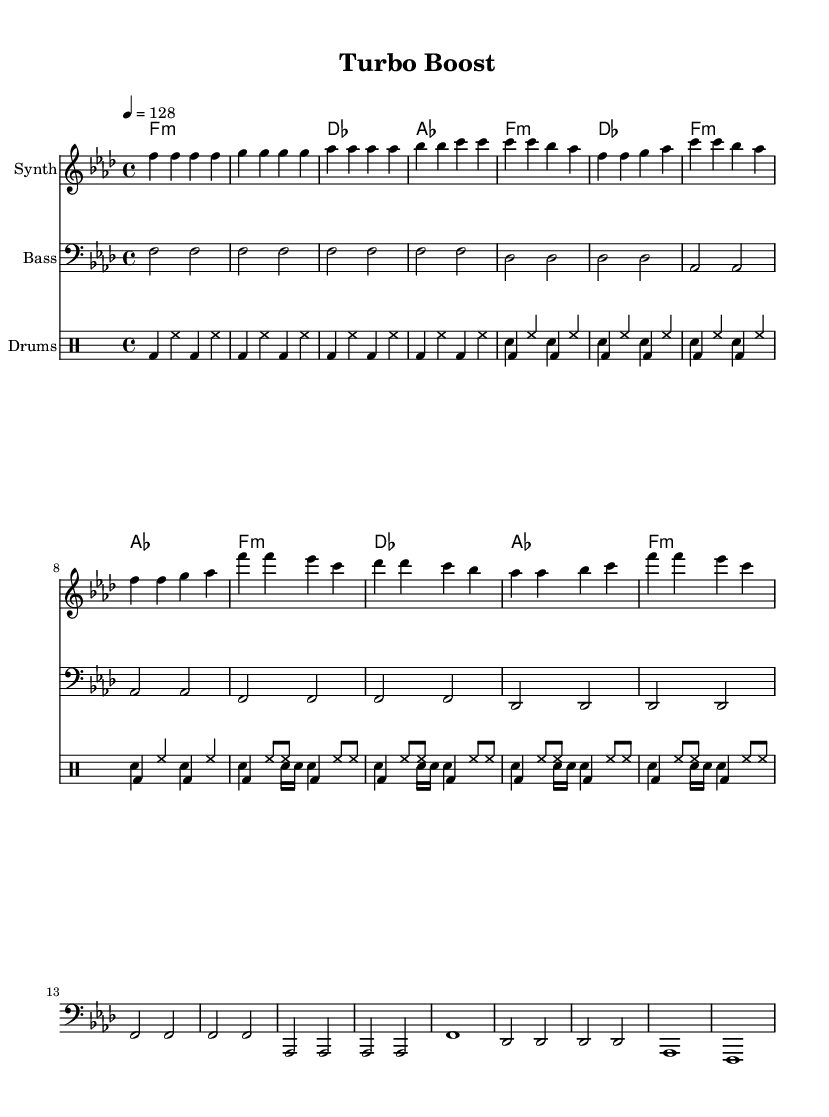What is the key signature of this music? The key signature is F minor, which is indicated by the presence of four flats (B, E, A, and D) located at the beginning of the score.
Answer: F minor What is the time signature of this music? The time signature is 4/4, which can be identified from the notation placed at the beginning of the piece. This means there are four beats per measure and a quarter note receives one beat.
Answer: 4/4 What is the tempo marking for this piece? The tempo marking is 128 BPM, which is specified at the start of the score with the note "tempo" indicating the beats per minute for the performance.
Answer: 128 How many bars are there in the verse section? The verse section contains 8 bars, which can be counted by examining the measures of the melody section that correspond specifically to the verse.
Answer: 8 What type of drum pattern is used in the intro? The drum pattern used in the intro is a basic four-on-the-floor pattern, recognizable by the bass drum hitting on every beat.
Answer: Four-on-the-floor How does the chorus differ from the verse in terms of rhythm complexity? The chorus has a more complex drum pattern than the verse, adding syncopated snare hits and increasing the rhythmic variation, which enhances the driving energy typical of K-Pop tracks.
Answer: More complex What electronic influences can be observed in this score? The electronic influences include the use of synthesized sounds in the melody and the way the rhythms mimic engine sounds, as well as the overall energetic arrangement typical of K-Pop electronic music.
Answer: Synthesized sounds 